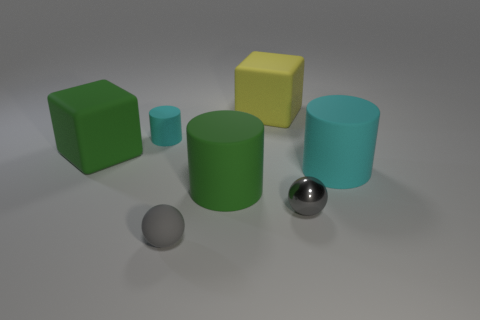Add 1 large gray balls. How many objects exist? 8 Subtract all cylinders. How many objects are left? 4 Add 7 small yellow cubes. How many small yellow cubes exist? 7 Subtract 0 green balls. How many objects are left? 7 Subtract all big yellow rubber objects. Subtract all small cyan rubber objects. How many objects are left? 5 Add 4 gray shiny things. How many gray shiny things are left? 5 